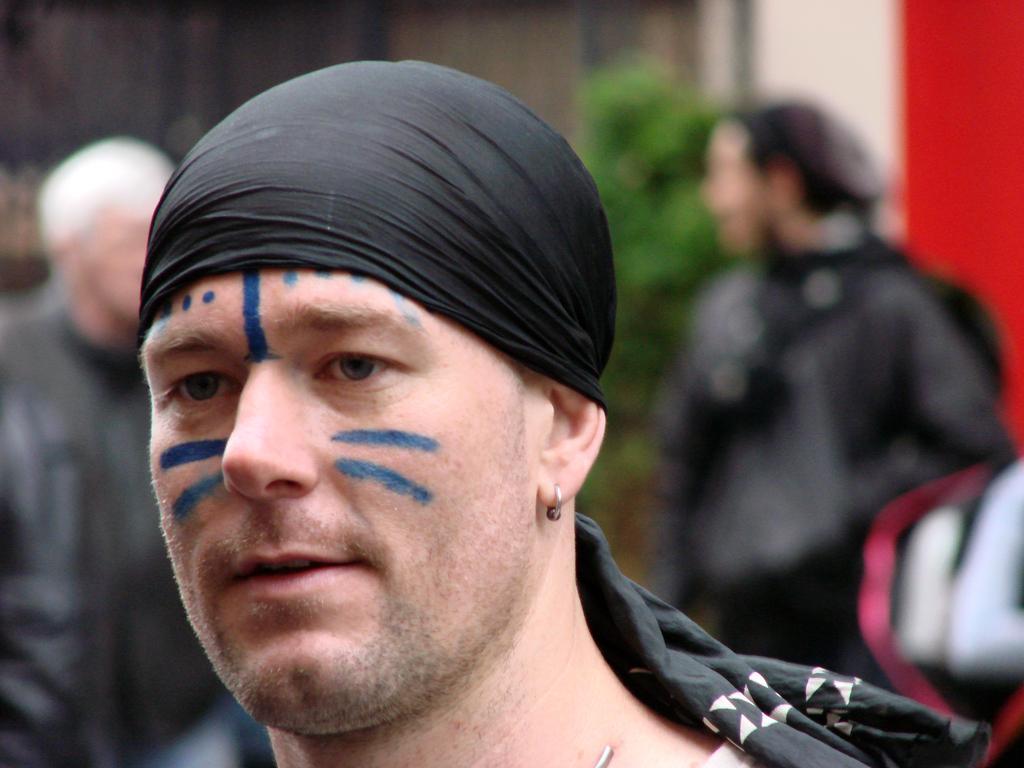Could you give a brief overview of what you see in this image? In this image we can see few people. There is a red color object at the right side of the image. There is a wall in the image. There is a plant in the image. A person is painted on his face in the image. 